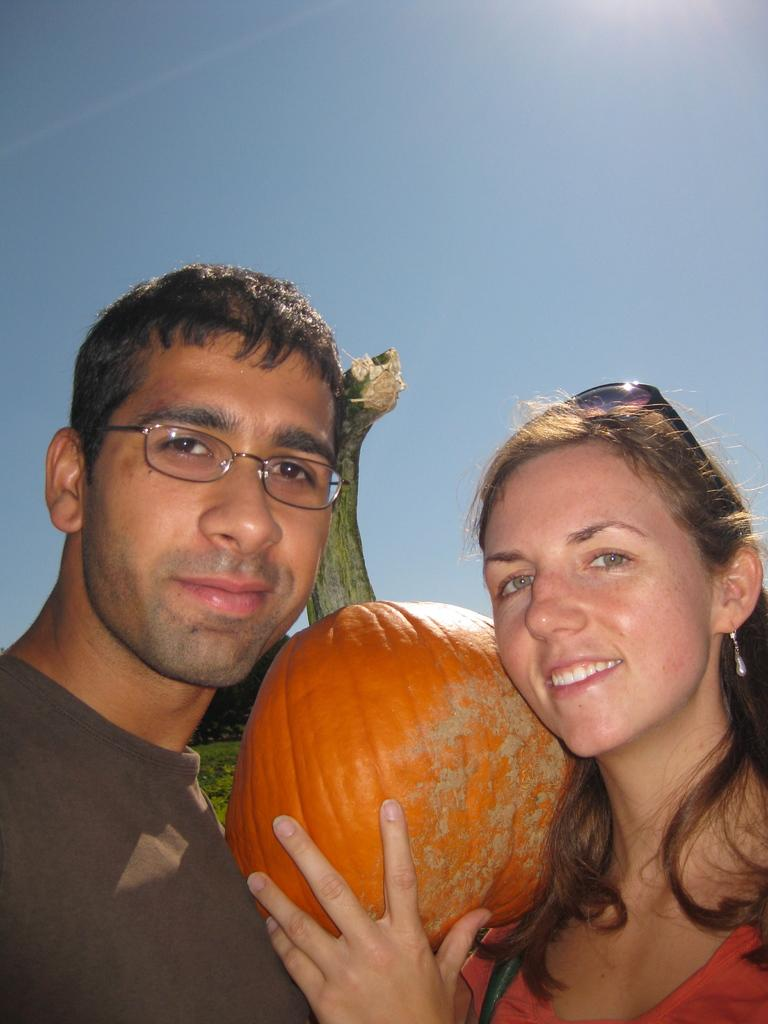Who are the people in the image? There is a man and a woman in the image. What are the positions of the man and the woman in the image? Both the man and the woman are standing. What expressions do the man and the woman have in the image? Both the man and the woman are smiling. What object is the woman holding in the image? The woman is holding a big pumpkin. What can be seen in the background of the image? The sky is visible in the image. What type of legal advice is the man providing to the woman in the image? There is no indication in the image that the man is providing legal advice to the woman, as they are both smiling and holding a pumpkin. What error is the woman trying to correct in the image? There is no error present in the image, as both the man and the woman are smiling and holding a pumpkin. 